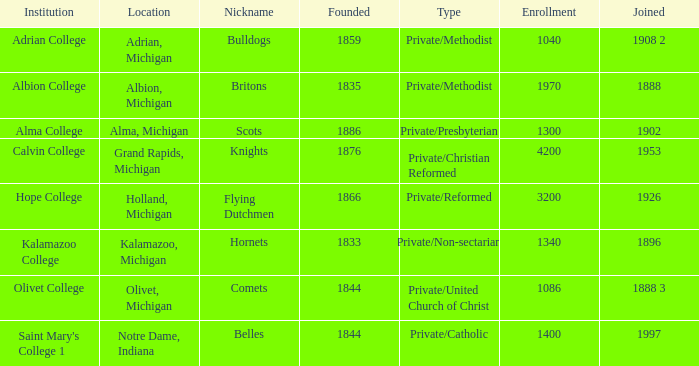How many classifications are included in the britons category? 1.0. 